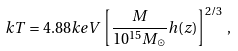Convert formula to latex. <formula><loc_0><loc_0><loc_500><loc_500>k T = 4 . 8 8 k e V \left [ \frac { M } { 1 0 ^ { 1 5 } M _ { \odot } } h ( z ) \right ] ^ { 2 / 3 } \, ,</formula> 